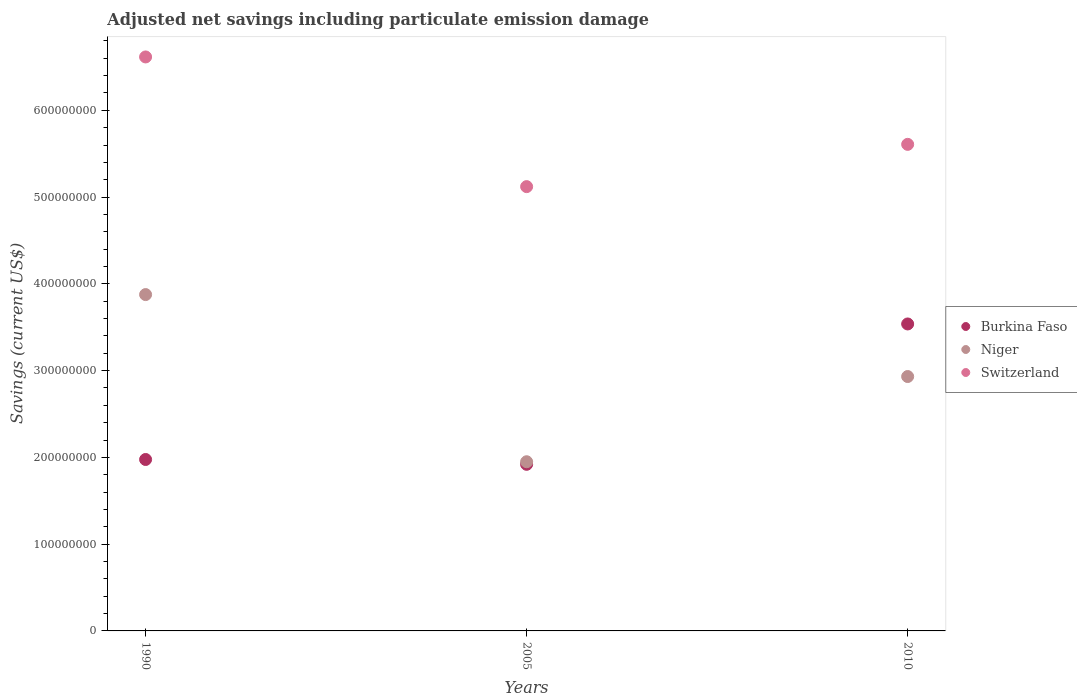Is the number of dotlines equal to the number of legend labels?
Give a very brief answer. Yes. What is the net savings in Niger in 2010?
Offer a very short reply. 2.93e+08. Across all years, what is the maximum net savings in Burkina Faso?
Your answer should be very brief. 3.54e+08. Across all years, what is the minimum net savings in Switzerland?
Provide a short and direct response. 5.12e+08. In which year was the net savings in Switzerland maximum?
Your answer should be very brief. 1990. In which year was the net savings in Niger minimum?
Offer a very short reply. 2005. What is the total net savings in Niger in the graph?
Your answer should be compact. 8.76e+08. What is the difference between the net savings in Burkina Faso in 2005 and that in 2010?
Make the answer very short. -1.62e+08. What is the difference between the net savings in Niger in 1990 and the net savings in Burkina Faso in 2005?
Give a very brief answer. 1.96e+08. What is the average net savings in Switzerland per year?
Keep it short and to the point. 5.78e+08. In the year 2005, what is the difference between the net savings in Switzerland and net savings in Burkina Faso?
Offer a very short reply. 3.20e+08. What is the ratio of the net savings in Burkina Faso in 1990 to that in 2010?
Provide a short and direct response. 0.56. Is the net savings in Niger in 1990 less than that in 2005?
Your answer should be compact. No. Is the difference between the net savings in Switzerland in 1990 and 2010 greater than the difference between the net savings in Burkina Faso in 1990 and 2010?
Make the answer very short. Yes. What is the difference between the highest and the second highest net savings in Niger?
Make the answer very short. 9.45e+07. What is the difference between the highest and the lowest net savings in Niger?
Provide a short and direct response. 1.93e+08. In how many years, is the net savings in Burkina Faso greater than the average net savings in Burkina Faso taken over all years?
Keep it short and to the point. 1. Is it the case that in every year, the sum of the net savings in Switzerland and net savings in Niger  is greater than the net savings in Burkina Faso?
Offer a terse response. Yes. Does the net savings in Switzerland monotonically increase over the years?
Offer a very short reply. No. Is the net savings in Niger strictly greater than the net savings in Burkina Faso over the years?
Keep it short and to the point. No. Is the net savings in Switzerland strictly less than the net savings in Niger over the years?
Your answer should be compact. No. Does the graph contain grids?
Keep it short and to the point. No. How are the legend labels stacked?
Provide a succinct answer. Vertical. What is the title of the graph?
Make the answer very short. Adjusted net savings including particulate emission damage. Does "Kosovo" appear as one of the legend labels in the graph?
Provide a succinct answer. No. What is the label or title of the Y-axis?
Provide a short and direct response. Savings (current US$). What is the Savings (current US$) of Burkina Faso in 1990?
Provide a succinct answer. 1.98e+08. What is the Savings (current US$) in Niger in 1990?
Your answer should be compact. 3.88e+08. What is the Savings (current US$) of Switzerland in 1990?
Your response must be concise. 6.61e+08. What is the Savings (current US$) in Burkina Faso in 2005?
Make the answer very short. 1.92e+08. What is the Savings (current US$) of Niger in 2005?
Give a very brief answer. 1.95e+08. What is the Savings (current US$) of Switzerland in 2005?
Your response must be concise. 5.12e+08. What is the Savings (current US$) in Burkina Faso in 2010?
Your answer should be compact. 3.54e+08. What is the Savings (current US$) of Niger in 2010?
Ensure brevity in your answer.  2.93e+08. What is the Savings (current US$) of Switzerland in 2010?
Give a very brief answer. 5.61e+08. Across all years, what is the maximum Savings (current US$) of Burkina Faso?
Provide a succinct answer. 3.54e+08. Across all years, what is the maximum Savings (current US$) in Niger?
Make the answer very short. 3.88e+08. Across all years, what is the maximum Savings (current US$) of Switzerland?
Offer a terse response. 6.61e+08. Across all years, what is the minimum Savings (current US$) of Burkina Faso?
Give a very brief answer. 1.92e+08. Across all years, what is the minimum Savings (current US$) of Niger?
Offer a very short reply. 1.95e+08. Across all years, what is the minimum Savings (current US$) of Switzerland?
Your answer should be very brief. 5.12e+08. What is the total Savings (current US$) of Burkina Faso in the graph?
Provide a succinct answer. 7.43e+08. What is the total Savings (current US$) of Niger in the graph?
Offer a terse response. 8.76e+08. What is the total Savings (current US$) of Switzerland in the graph?
Provide a succinct answer. 1.73e+09. What is the difference between the Savings (current US$) of Burkina Faso in 1990 and that in 2005?
Offer a terse response. 5.55e+06. What is the difference between the Savings (current US$) of Niger in 1990 and that in 2005?
Make the answer very short. 1.93e+08. What is the difference between the Savings (current US$) in Switzerland in 1990 and that in 2005?
Offer a very short reply. 1.49e+08. What is the difference between the Savings (current US$) in Burkina Faso in 1990 and that in 2010?
Make the answer very short. -1.56e+08. What is the difference between the Savings (current US$) of Niger in 1990 and that in 2010?
Ensure brevity in your answer.  9.45e+07. What is the difference between the Savings (current US$) in Switzerland in 1990 and that in 2010?
Keep it short and to the point. 1.01e+08. What is the difference between the Savings (current US$) in Burkina Faso in 2005 and that in 2010?
Offer a very short reply. -1.62e+08. What is the difference between the Savings (current US$) in Niger in 2005 and that in 2010?
Keep it short and to the point. -9.82e+07. What is the difference between the Savings (current US$) of Switzerland in 2005 and that in 2010?
Keep it short and to the point. -4.87e+07. What is the difference between the Savings (current US$) in Burkina Faso in 1990 and the Savings (current US$) in Niger in 2005?
Your answer should be very brief. 2.60e+06. What is the difference between the Savings (current US$) in Burkina Faso in 1990 and the Savings (current US$) in Switzerland in 2005?
Ensure brevity in your answer.  -3.14e+08. What is the difference between the Savings (current US$) of Niger in 1990 and the Savings (current US$) of Switzerland in 2005?
Offer a very short reply. -1.24e+08. What is the difference between the Savings (current US$) in Burkina Faso in 1990 and the Savings (current US$) in Niger in 2010?
Make the answer very short. -9.56e+07. What is the difference between the Savings (current US$) of Burkina Faso in 1990 and the Savings (current US$) of Switzerland in 2010?
Give a very brief answer. -3.63e+08. What is the difference between the Savings (current US$) in Niger in 1990 and the Savings (current US$) in Switzerland in 2010?
Offer a very short reply. -1.73e+08. What is the difference between the Savings (current US$) in Burkina Faso in 2005 and the Savings (current US$) in Niger in 2010?
Ensure brevity in your answer.  -1.01e+08. What is the difference between the Savings (current US$) in Burkina Faso in 2005 and the Savings (current US$) in Switzerland in 2010?
Offer a terse response. -3.69e+08. What is the difference between the Savings (current US$) of Niger in 2005 and the Savings (current US$) of Switzerland in 2010?
Provide a short and direct response. -3.66e+08. What is the average Savings (current US$) in Burkina Faso per year?
Give a very brief answer. 2.48e+08. What is the average Savings (current US$) of Niger per year?
Make the answer very short. 2.92e+08. What is the average Savings (current US$) in Switzerland per year?
Keep it short and to the point. 5.78e+08. In the year 1990, what is the difference between the Savings (current US$) in Burkina Faso and Savings (current US$) in Niger?
Your answer should be very brief. -1.90e+08. In the year 1990, what is the difference between the Savings (current US$) in Burkina Faso and Savings (current US$) in Switzerland?
Your answer should be very brief. -4.64e+08. In the year 1990, what is the difference between the Savings (current US$) in Niger and Savings (current US$) in Switzerland?
Offer a very short reply. -2.74e+08. In the year 2005, what is the difference between the Savings (current US$) of Burkina Faso and Savings (current US$) of Niger?
Ensure brevity in your answer.  -2.96e+06. In the year 2005, what is the difference between the Savings (current US$) of Burkina Faso and Savings (current US$) of Switzerland?
Provide a succinct answer. -3.20e+08. In the year 2005, what is the difference between the Savings (current US$) of Niger and Savings (current US$) of Switzerland?
Provide a short and direct response. -3.17e+08. In the year 2010, what is the difference between the Savings (current US$) in Burkina Faso and Savings (current US$) in Niger?
Your answer should be very brief. 6.06e+07. In the year 2010, what is the difference between the Savings (current US$) in Burkina Faso and Savings (current US$) in Switzerland?
Provide a short and direct response. -2.07e+08. In the year 2010, what is the difference between the Savings (current US$) in Niger and Savings (current US$) in Switzerland?
Your response must be concise. -2.68e+08. What is the ratio of the Savings (current US$) in Burkina Faso in 1990 to that in 2005?
Your answer should be very brief. 1.03. What is the ratio of the Savings (current US$) in Niger in 1990 to that in 2005?
Give a very brief answer. 1.99. What is the ratio of the Savings (current US$) of Switzerland in 1990 to that in 2005?
Your answer should be compact. 1.29. What is the ratio of the Savings (current US$) of Burkina Faso in 1990 to that in 2010?
Offer a terse response. 0.56. What is the ratio of the Savings (current US$) of Niger in 1990 to that in 2010?
Provide a short and direct response. 1.32. What is the ratio of the Savings (current US$) of Switzerland in 1990 to that in 2010?
Ensure brevity in your answer.  1.18. What is the ratio of the Savings (current US$) in Burkina Faso in 2005 to that in 2010?
Offer a very short reply. 0.54. What is the ratio of the Savings (current US$) in Niger in 2005 to that in 2010?
Give a very brief answer. 0.67. What is the ratio of the Savings (current US$) in Switzerland in 2005 to that in 2010?
Keep it short and to the point. 0.91. What is the difference between the highest and the second highest Savings (current US$) of Burkina Faso?
Offer a terse response. 1.56e+08. What is the difference between the highest and the second highest Savings (current US$) in Niger?
Provide a short and direct response. 9.45e+07. What is the difference between the highest and the second highest Savings (current US$) in Switzerland?
Provide a succinct answer. 1.01e+08. What is the difference between the highest and the lowest Savings (current US$) of Burkina Faso?
Ensure brevity in your answer.  1.62e+08. What is the difference between the highest and the lowest Savings (current US$) of Niger?
Make the answer very short. 1.93e+08. What is the difference between the highest and the lowest Savings (current US$) in Switzerland?
Keep it short and to the point. 1.49e+08. 